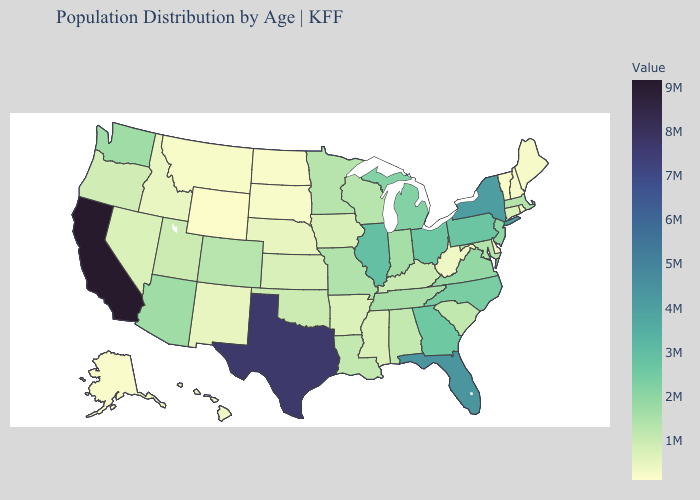Does California have the highest value in the USA?
Write a very short answer. Yes. Does California have the highest value in the USA?
Give a very brief answer. Yes. Does New Mexico have the lowest value in the West?
Be succinct. No. Does Vermont have the lowest value in the Northeast?
Concise answer only. Yes. Does Idaho have the highest value in the West?
Give a very brief answer. No. Among the states that border Tennessee , which have the lowest value?
Give a very brief answer. Arkansas. 